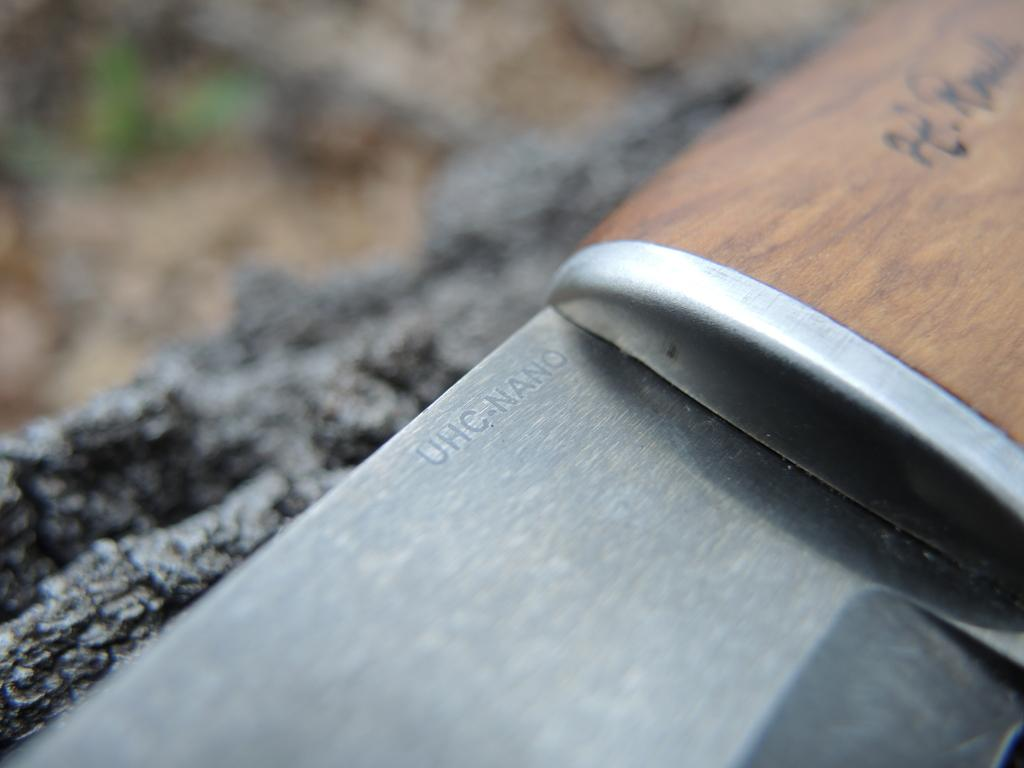What object can be seen in the image that is typically used for cutting? There is a knife in the image. Where is the knife located in the image? The knife is on a rock. What type of rest can be seen being taken by the knife in the image? The knife is an inanimate object and does not take rest. Is there a list present in the image? There is no mention of a list in the provided facts about the image. 